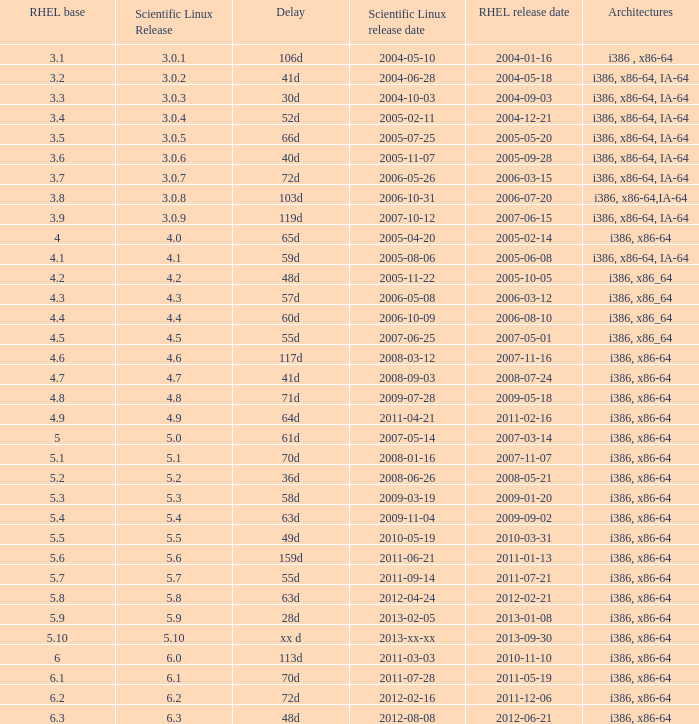Name the delay when scientific linux release is 5.10 Xx d. 